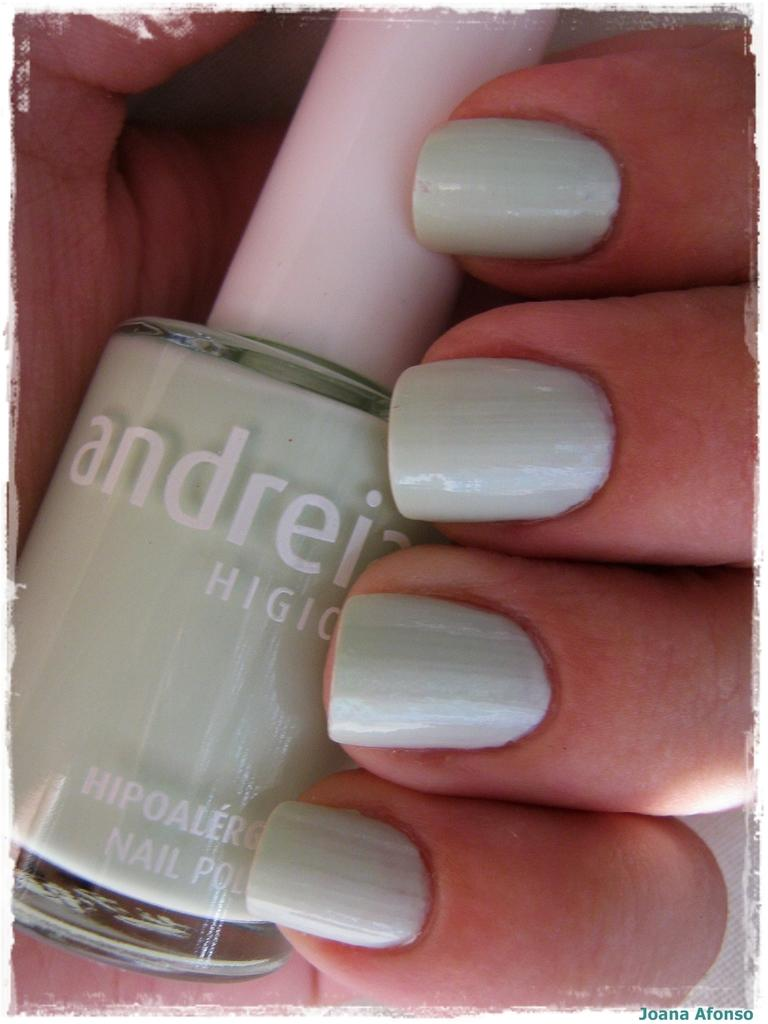Provide a one-sentence caption for the provided image. light green nail pollish with the brand andreia and a girl hand holiding it. 